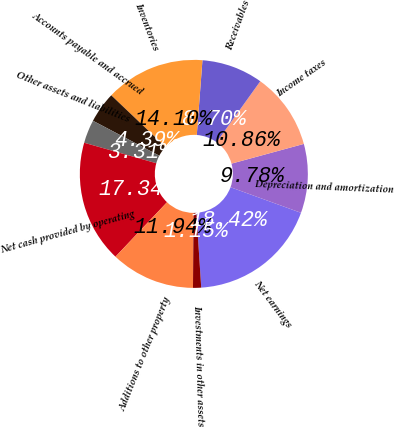<chart> <loc_0><loc_0><loc_500><loc_500><pie_chart><fcel>Net earnings<fcel>Depreciation and amortization<fcel>Income taxes<fcel>Receivables<fcel>Inventories<fcel>Accounts payable and accrued<fcel>Other assets and liabilities<fcel>Net cash provided by operating<fcel>Additions to other property<fcel>Investments in other assets<nl><fcel>18.42%<fcel>9.78%<fcel>10.86%<fcel>8.7%<fcel>14.1%<fcel>4.39%<fcel>3.31%<fcel>17.34%<fcel>11.94%<fcel>1.15%<nl></chart> 